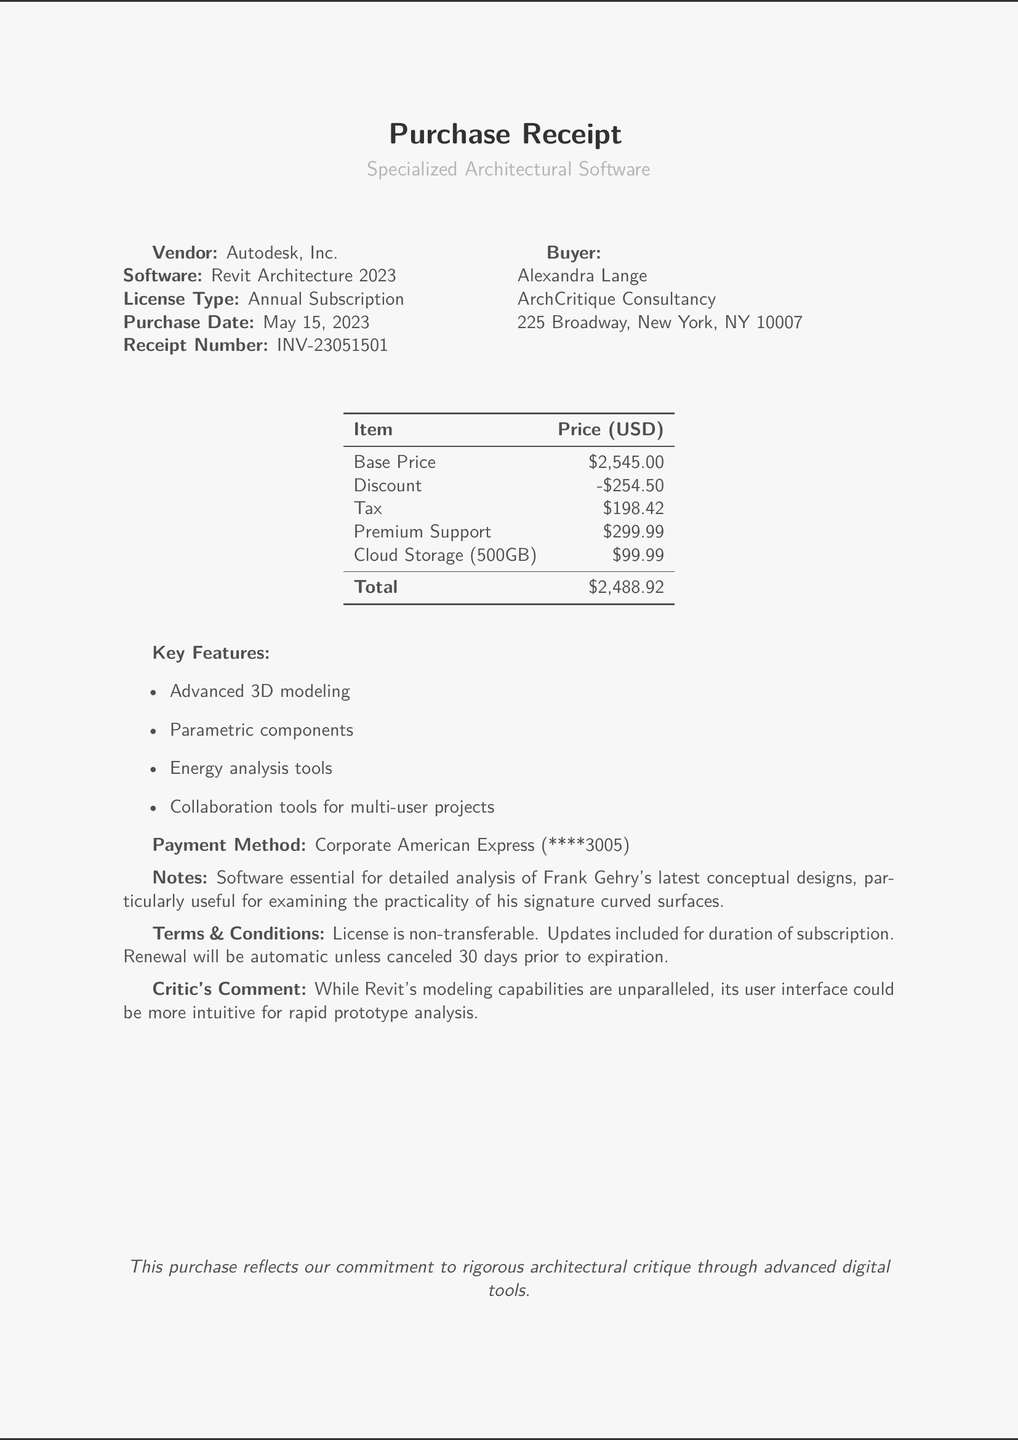what is the software purchased? The software purchased is listed as Revit Architecture 2023.
Answer: Revit Architecture 2023 who is the vendor? The vendor mentioned in the document is Autodesk, Inc.
Answer: Autodesk, Inc what is the purchase date? The purchase date indicated in the document is May 15, 2023.
Answer: May 15, 2023 what is the total price after tax and discounts? The total price shows the final amount after applying the discount and adding tax, which is $2,488.92.
Answer: $2,488.92 what is the base price of the software? The base price is specified as $2,545.00.
Answer: $2,545.00 how much is the premium support service? The document states that the premium support service costs $299.99.
Answer: $299.99 which payment method was used for the purchase? The payment method documented is Corporate American Express.
Answer: Corporate American Express what is included in the terms and conditions regarding the license? The license is non-transferable and includes updates for the duration of the subscription.
Answer: non-transferable what type of additional service is mentioned besides premium support? An additional service mentioned is Cloud Storage (500GB).
Answer: Cloud Storage (500GB) what is the critic's comment about the software? The critic's comment highlights the unparalleled modeling capabilities but notes the user interface could be improved.
Answer: unparalleled modeling capabilities, user interface could be improved 